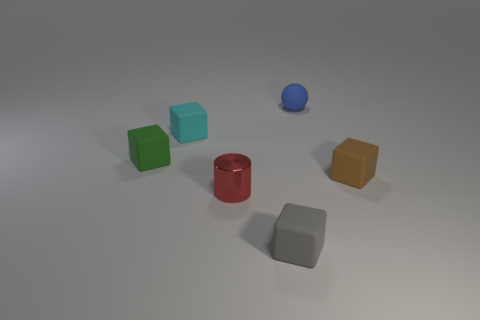Subtract all brown blocks. How many blocks are left? 3 Subtract all brown blocks. How many blocks are left? 3 Add 3 green rubber things. How many objects exist? 9 Subtract all purple cubes. Subtract all yellow cylinders. How many cubes are left? 4 Subtract all cubes. How many objects are left? 2 Subtract all tiny blue matte cylinders. Subtract all tiny rubber things. How many objects are left? 1 Add 1 tiny cyan matte blocks. How many tiny cyan matte blocks are left? 2 Add 4 gray cubes. How many gray cubes exist? 5 Subtract 1 green blocks. How many objects are left? 5 